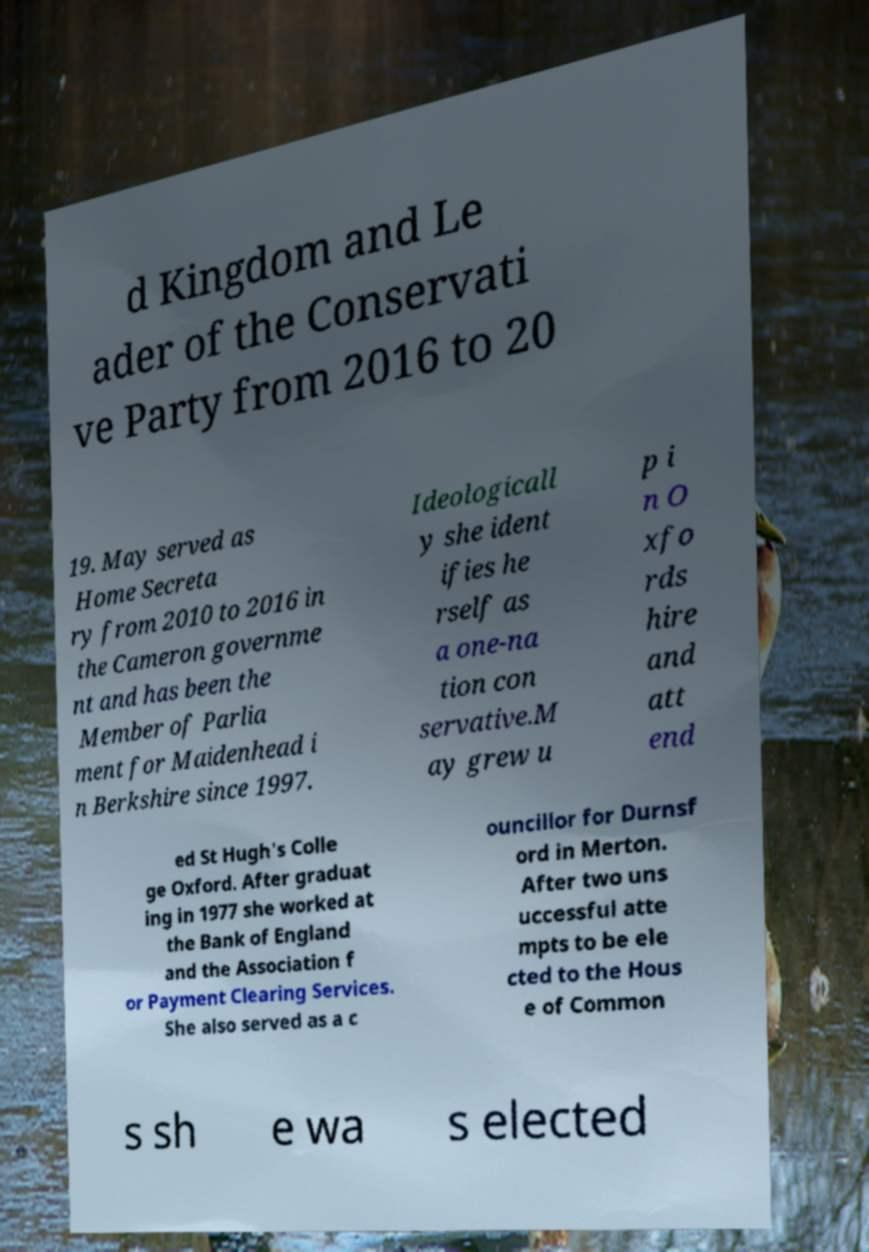There's text embedded in this image that I need extracted. Can you transcribe it verbatim? d Kingdom and Le ader of the Conservati ve Party from 2016 to 20 19. May served as Home Secreta ry from 2010 to 2016 in the Cameron governme nt and has been the Member of Parlia ment for Maidenhead i n Berkshire since 1997. Ideologicall y she ident ifies he rself as a one-na tion con servative.M ay grew u p i n O xfo rds hire and att end ed St Hugh's Colle ge Oxford. After graduat ing in 1977 she worked at the Bank of England and the Association f or Payment Clearing Services. She also served as a c ouncillor for Durnsf ord in Merton. After two uns uccessful atte mpts to be ele cted to the Hous e of Common s sh e wa s elected 